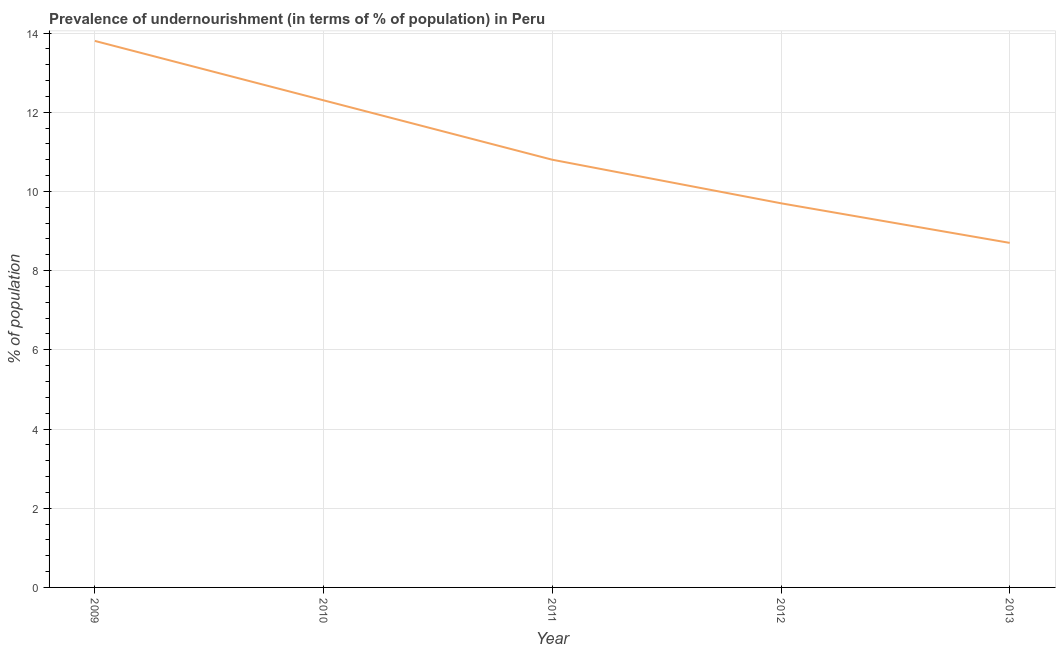What is the percentage of undernourished population in 2011?
Keep it short and to the point. 10.8. Across all years, what is the maximum percentage of undernourished population?
Keep it short and to the point. 13.8. Across all years, what is the minimum percentage of undernourished population?
Provide a short and direct response. 8.7. In which year was the percentage of undernourished population maximum?
Your answer should be very brief. 2009. In which year was the percentage of undernourished population minimum?
Provide a short and direct response. 2013. What is the sum of the percentage of undernourished population?
Ensure brevity in your answer.  55.3. What is the difference between the percentage of undernourished population in 2009 and 2012?
Your answer should be compact. 4.1. What is the average percentage of undernourished population per year?
Keep it short and to the point. 11.06. What is the median percentage of undernourished population?
Offer a very short reply. 10.8. In how many years, is the percentage of undernourished population greater than 7.2 %?
Offer a terse response. 5. What is the ratio of the percentage of undernourished population in 2011 to that in 2012?
Make the answer very short. 1.11. Is the percentage of undernourished population in 2012 less than that in 2013?
Your answer should be compact. No. Is the difference between the percentage of undernourished population in 2011 and 2013 greater than the difference between any two years?
Offer a very short reply. No. What is the difference between the highest and the lowest percentage of undernourished population?
Your answer should be compact. 5.1. Does the percentage of undernourished population monotonically increase over the years?
Your response must be concise. No. How many lines are there?
Provide a succinct answer. 1. How many years are there in the graph?
Offer a terse response. 5. Are the values on the major ticks of Y-axis written in scientific E-notation?
Your response must be concise. No. Does the graph contain grids?
Offer a very short reply. Yes. What is the title of the graph?
Make the answer very short. Prevalence of undernourishment (in terms of % of population) in Peru. What is the label or title of the X-axis?
Your answer should be compact. Year. What is the label or title of the Y-axis?
Your response must be concise. % of population. What is the % of population of 2010?
Your answer should be compact. 12.3. What is the % of population of 2012?
Provide a succinct answer. 9.7. What is the difference between the % of population in 2009 and 2012?
Your response must be concise. 4.1. What is the difference between the % of population in 2009 and 2013?
Offer a very short reply. 5.1. What is the difference between the % of population in 2010 and 2011?
Offer a terse response. 1.5. What is the difference between the % of population in 2010 and 2012?
Give a very brief answer. 2.6. What is the difference between the % of population in 2012 and 2013?
Keep it short and to the point. 1. What is the ratio of the % of population in 2009 to that in 2010?
Offer a very short reply. 1.12. What is the ratio of the % of population in 2009 to that in 2011?
Your response must be concise. 1.28. What is the ratio of the % of population in 2009 to that in 2012?
Offer a terse response. 1.42. What is the ratio of the % of population in 2009 to that in 2013?
Offer a terse response. 1.59. What is the ratio of the % of population in 2010 to that in 2011?
Your answer should be very brief. 1.14. What is the ratio of the % of population in 2010 to that in 2012?
Offer a terse response. 1.27. What is the ratio of the % of population in 2010 to that in 2013?
Provide a short and direct response. 1.41. What is the ratio of the % of population in 2011 to that in 2012?
Ensure brevity in your answer.  1.11. What is the ratio of the % of population in 2011 to that in 2013?
Offer a terse response. 1.24. What is the ratio of the % of population in 2012 to that in 2013?
Make the answer very short. 1.11. 